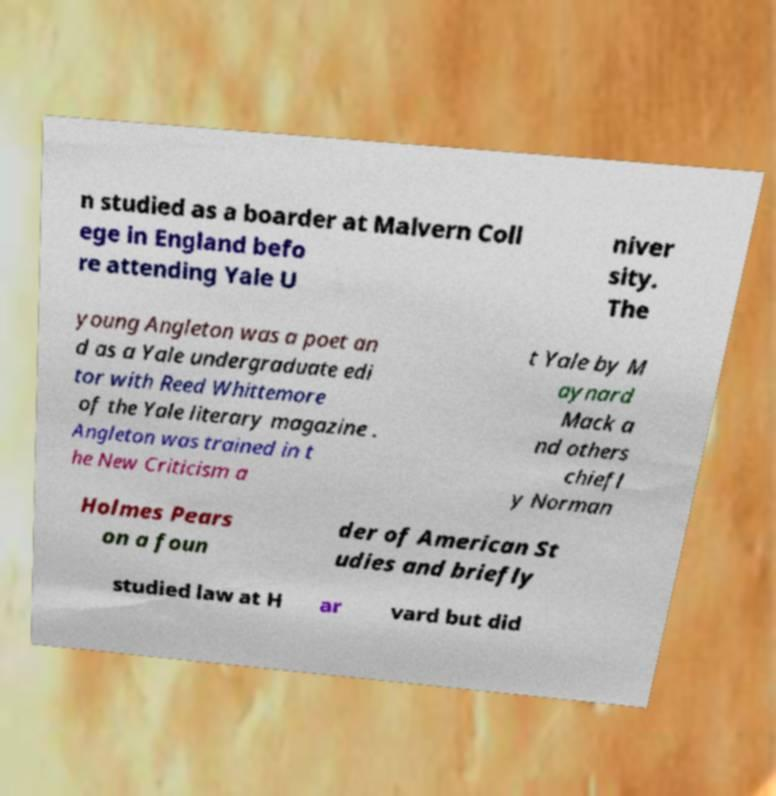Could you assist in decoding the text presented in this image and type it out clearly? n studied as a boarder at Malvern Coll ege in England befo re attending Yale U niver sity. The young Angleton was a poet an d as a Yale undergraduate edi tor with Reed Whittemore of the Yale literary magazine . Angleton was trained in t he New Criticism a t Yale by M aynard Mack a nd others chiefl y Norman Holmes Pears on a foun der of American St udies and briefly studied law at H ar vard but did 